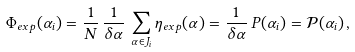Convert formula to latex. <formula><loc_0><loc_0><loc_500><loc_500>\Phi _ { e x p } ( \alpha _ { i } ) = \frac { 1 } { N } \, \frac { 1 } { \delta \alpha } \, \sum _ { \alpha \in J _ { i } } \eta _ { e x p } ( \alpha ) = \frac { 1 } { \delta \alpha } \, P ( \alpha _ { i } ) = \mathcal { P } ( \alpha _ { i } ) \, ,</formula> 